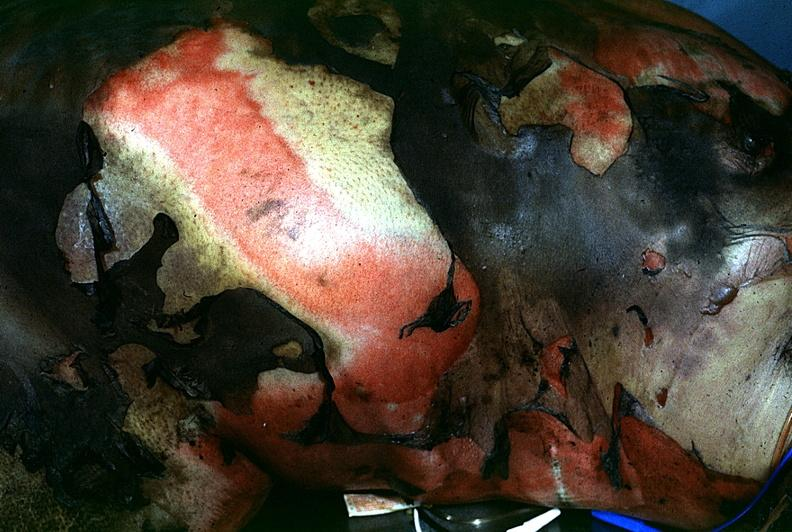what does this image show?
Answer the question using a single word or phrase. Thermal burn 